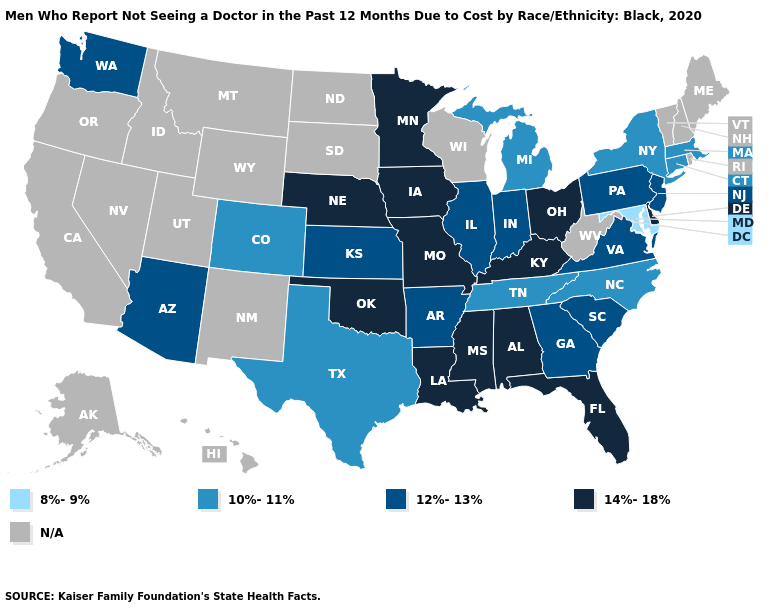Does Michigan have the lowest value in the MidWest?
Quick response, please. Yes. What is the lowest value in states that border Texas?
Be succinct. 12%-13%. Name the states that have a value in the range N/A?
Quick response, please. Alaska, California, Hawaii, Idaho, Maine, Montana, Nevada, New Hampshire, New Mexico, North Dakota, Oregon, Rhode Island, South Dakota, Utah, Vermont, West Virginia, Wisconsin, Wyoming. What is the highest value in the USA?
Be succinct. 14%-18%. What is the value of Delaware?
Short answer required. 14%-18%. Does the first symbol in the legend represent the smallest category?
Answer briefly. Yes. What is the highest value in the MidWest ?
Quick response, please. 14%-18%. What is the value of Arizona?
Answer briefly. 12%-13%. Does the map have missing data?
Give a very brief answer. Yes. What is the lowest value in the MidWest?
Answer briefly. 10%-11%. Among the states that border Wyoming , which have the lowest value?
Answer briefly. Colorado. Name the states that have a value in the range 10%-11%?
Concise answer only. Colorado, Connecticut, Massachusetts, Michigan, New York, North Carolina, Tennessee, Texas. What is the lowest value in the Northeast?
Quick response, please. 10%-11%. Does the map have missing data?
Quick response, please. Yes. What is the value of West Virginia?
Answer briefly. N/A. 